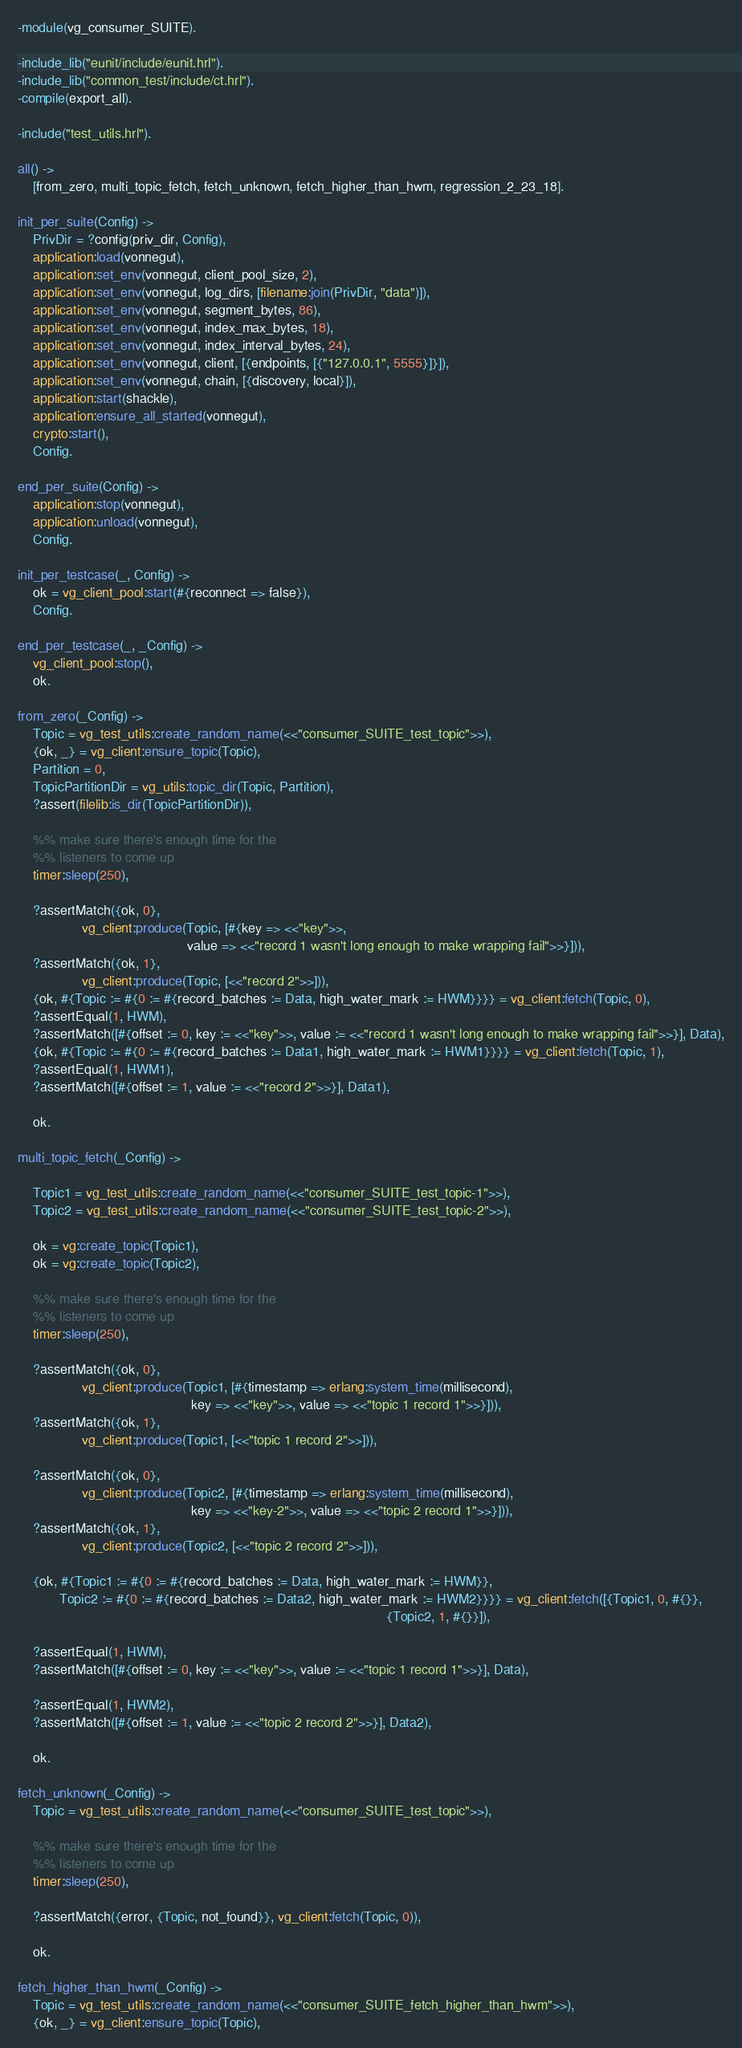<code> <loc_0><loc_0><loc_500><loc_500><_Erlang_>-module(vg_consumer_SUITE).

-include_lib("eunit/include/eunit.hrl").
-include_lib("common_test/include/ct.hrl").
-compile(export_all).

-include("test_utils.hrl").

all() ->
    [from_zero, multi_topic_fetch, fetch_unknown, fetch_higher_than_hwm, regression_2_23_18].

init_per_suite(Config) ->
    PrivDir = ?config(priv_dir, Config),
    application:load(vonnegut),
    application:set_env(vonnegut, client_pool_size, 2),
    application:set_env(vonnegut, log_dirs, [filename:join(PrivDir, "data")]),
    application:set_env(vonnegut, segment_bytes, 86),
    application:set_env(vonnegut, index_max_bytes, 18),
    application:set_env(vonnegut, index_interval_bytes, 24),
    application:set_env(vonnegut, client, [{endpoints, [{"127.0.0.1", 5555}]}]),
    application:set_env(vonnegut, chain, [{discovery, local}]),
    application:start(shackle),
    application:ensure_all_started(vonnegut),
    crypto:start(),
    Config.

end_per_suite(Config) ->
    application:stop(vonnegut),
    application:unload(vonnegut),
    Config.

init_per_testcase(_, Config) ->
    ok = vg_client_pool:start(#{reconnect => false}),
    Config.

end_per_testcase(_, _Config) ->
    vg_client_pool:stop(),
    ok.

from_zero(_Config) ->
    Topic = vg_test_utils:create_random_name(<<"consumer_SUITE_test_topic">>),
    {ok, _} = vg_client:ensure_topic(Topic),
    Partition = 0,
    TopicPartitionDir = vg_utils:topic_dir(Topic, Partition),
    ?assert(filelib:is_dir(TopicPartitionDir)),

    %% make sure there's enough time for the
    %% listeners to come up
    timer:sleep(250),

    ?assertMatch({ok, 0},
                 vg_client:produce(Topic, [#{key => <<"key">>,
                                             value => <<"record 1 wasn't long enough to make wrapping fail">>}])),
    ?assertMatch({ok, 1},
                 vg_client:produce(Topic, [<<"record 2">>])),
    {ok, #{Topic := #{0 := #{record_batches := Data, high_water_mark := HWM}}}} = vg_client:fetch(Topic, 0),
    ?assertEqual(1, HWM),
    ?assertMatch([#{offset := 0, key := <<"key">>, value := <<"record 1 wasn't long enough to make wrapping fail">>}], Data),
    {ok, #{Topic := #{0 := #{record_batches := Data1, high_water_mark := HWM1}}}} = vg_client:fetch(Topic, 1),
    ?assertEqual(1, HWM1),
    ?assertMatch([#{offset := 1, value := <<"record 2">>}], Data1),

    ok.

multi_topic_fetch(_Config) ->

    Topic1 = vg_test_utils:create_random_name(<<"consumer_SUITE_test_topic-1">>),
    Topic2 = vg_test_utils:create_random_name(<<"consumer_SUITE_test_topic-2">>),

    ok = vg:create_topic(Topic1),
    ok = vg:create_topic(Topic2),

    %% make sure there's enough time for the
    %% listeners to come up
    timer:sleep(250),

    ?assertMatch({ok, 0},
                 vg_client:produce(Topic1, [#{timestamp => erlang:system_time(millisecond),
                                              key => <<"key">>, value => <<"topic 1 record 1">>}])),
    ?assertMatch({ok, 1},
                 vg_client:produce(Topic1, [<<"topic 1 record 2">>])),

    ?assertMatch({ok, 0},
                 vg_client:produce(Topic2, [#{timestamp => erlang:system_time(millisecond),
                                              key => <<"key-2">>, value => <<"topic 2 record 1">>}])),
    ?assertMatch({ok, 1},
                 vg_client:produce(Topic2, [<<"topic 2 record 2">>])),

    {ok, #{Topic1 := #{0 := #{record_batches := Data, high_water_mark := HWM}},
           Topic2 := #{0 := #{record_batches := Data2, high_water_mark := HWM2}}}} = vg_client:fetch([{Topic1, 0, #{}},
                                                                                                  {Topic2, 1, #{}}]),

    ?assertEqual(1, HWM),
    ?assertMatch([#{offset := 0, key := <<"key">>, value := <<"topic 1 record 1">>}], Data),

    ?assertEqual(1, HWM2),
    ?assertMatch([#{offset := 1, value := <<"topic 2 record 2">>}], Data2),

    ok.

fetch_unknown(_Config) ->
    Topic = vg_test_utils:create_random_name(<<"consumer_SUITE_test_topic">>),

    %% make sure there's enough time for the
    %% listeners to come up
    timer:sleep(250),

    ?assertMatch({error, {Topic, not_found}}, vg_client:fetch(Topic, 0)),

    ok.

fetch_higher_than_hwm(_Config) ->
    Topic = vg_test_utils:create_random_name(<<"consumer_SUITE_fetch_higher_than_hwm">>),
    {ok, _} = vg_client:ensure_topic(Topic),</code> 